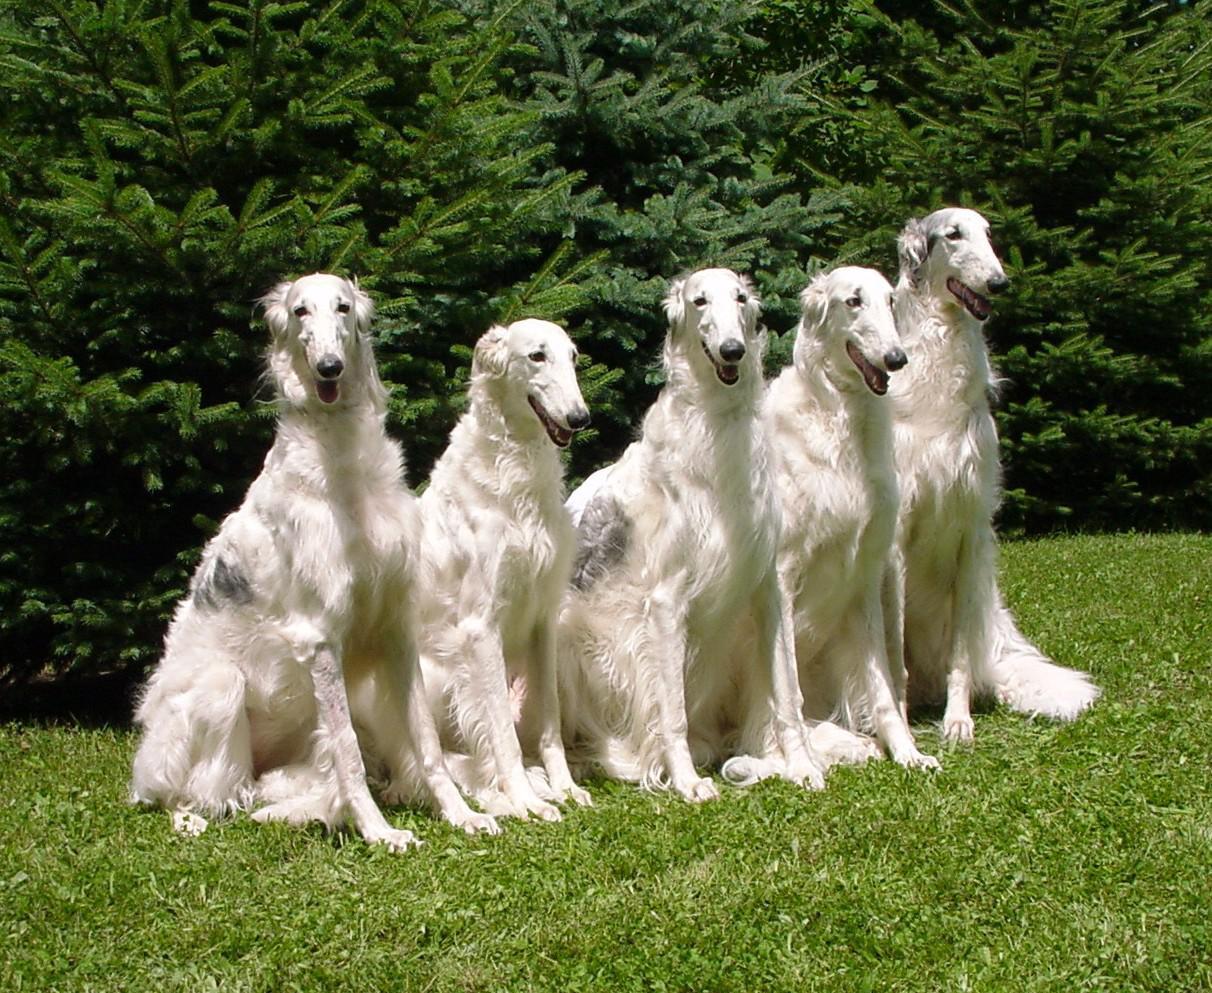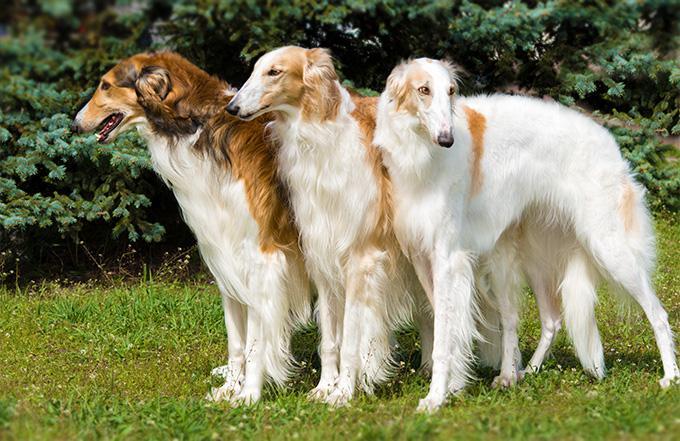The first image is the image on the left, the second image is the image on the right. For the images displayed, is the sentence "Every dog has its mouth open." factually correct? Answer yes or no. No. The first image is the image on the left, the second image is the image on the right. Examine the images to the left and right. Is the description "There are at most 2 dogs." accurate? Answer yes or no. No. 